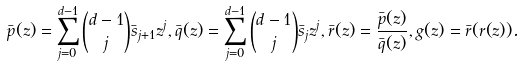<formula> <loc_0><loc_0><loc_500><loc_500>\bar { p } ( z ) = \sum _ { j = 0 } ^ { d - 1 } { d - 1 \choose j } \bar { s } _ { j + 1 } z ^ { j } , \bar { q } ( z ) = \sum _ { j = 0 } ^ { d - 1 } { d - 1 \choose j } \bar { s } _ { j } z ^ { j } , \bar { r } ( z ) = \frac { \bar { p } ( z ) } { \bar { q } ( z ) } , g ( z ) = \bar { r } ( r ( z ) ) .</formula> 